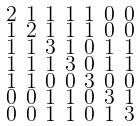<formula> <loc_0><loc_0><loc_500><loc_500>\begin{smallmatrix} 2 & 1 & 1 & 1 & 1 & 0 & 0 \\ 1 & 2 & 1 & 1 & 1 & 0 & 0 \\ 1 & 1 & 3 & 1 & 0 & 1 & 1 \\ 1 & 1 & 1 & 3 & 0 & 1 & 1 \\ 1 & 1 & 0 & 0 & 3 & 0 & 0 \\ 0 & 0 & 1 & 1 & 0 & 3 & 1 \\ 0 & 0 & 1 & 1 & 0 & 1 & 3 \end{smallmatrix}</formula> 